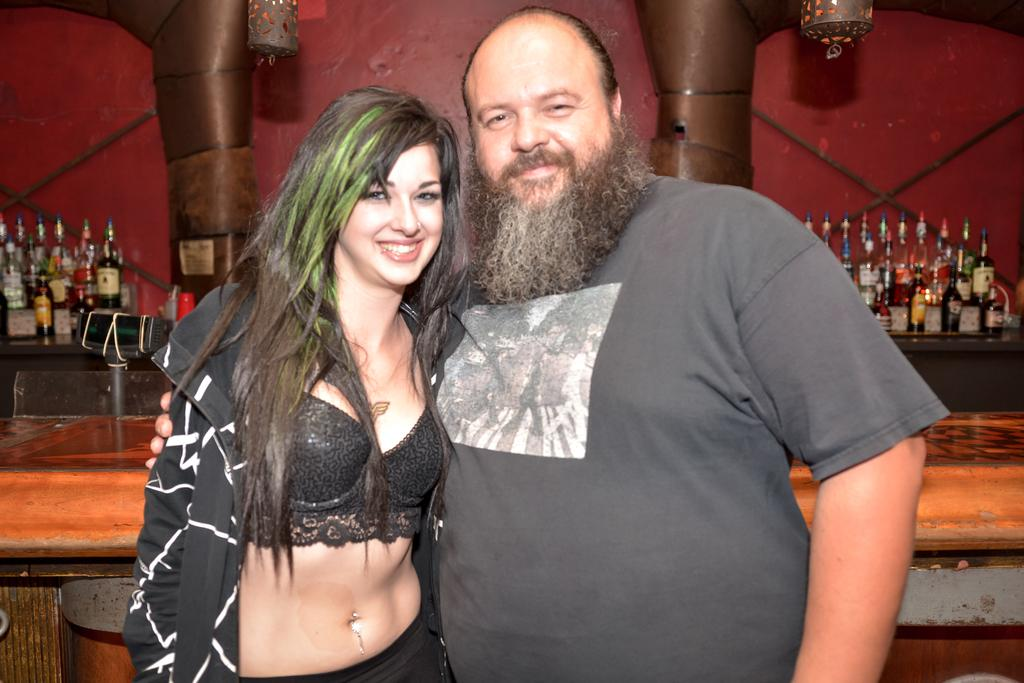How many people are present in the image? There are two people, a man and a woman, present in the image. What are the people in the image doing? Both the man and the woman are standing and smiling. What can be seen in the background of the image? There are bottles and a wall in the background of the image. What type of creature is crawling on the wall in the image? There is no creature crawling on the wall in the image; it is a plain wall in the background. 